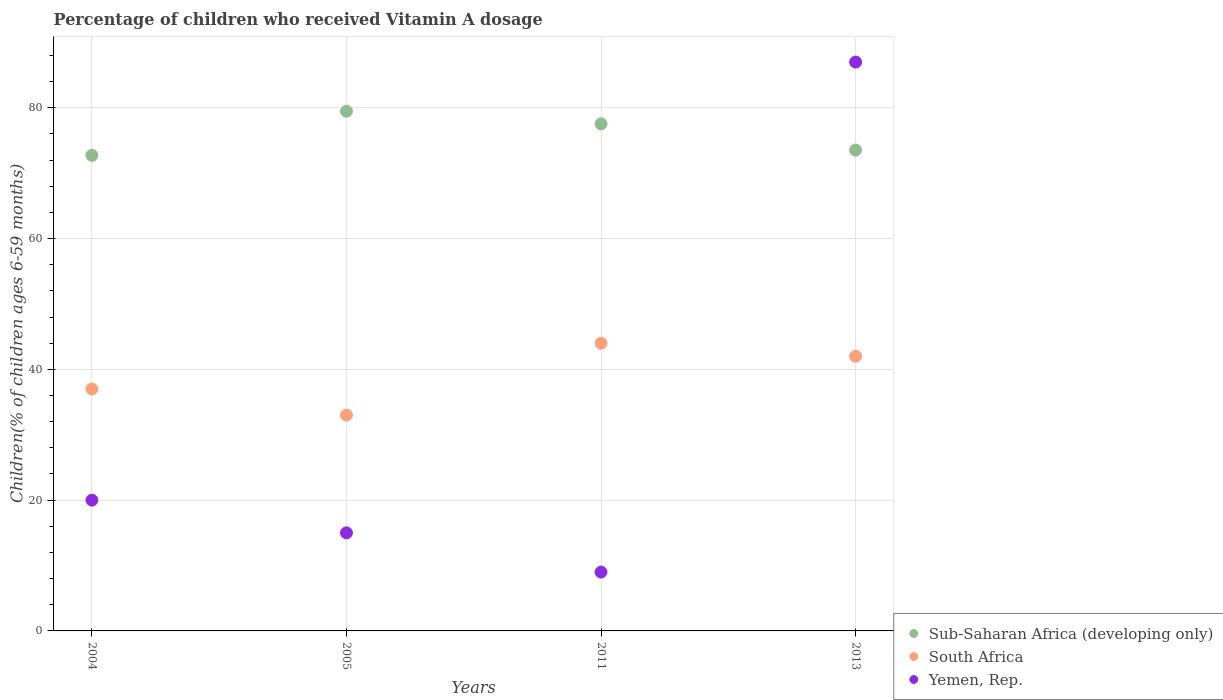What is the percentage of children who received Vitamin A dosage in Yemen, Rep. in 2005?
Keep it short and to the point. 15. Across all years, what is the maximum percentage of children who received Vitamin A dosage in Sub-Saharan Africa (developing only)?
Make the answer very short. 79.48. Across all years, what is the minimum percentage of children who received Vitamin A dosage in Sub-Saharan Africa (developing only)?
Ensure brevity in your answer.  72.73. In which year was the percentage of children who received Vitamin A dosage in Sub-Saharan Africa (developing only) minimum?
Keep it short and to the point. 2004. What is the total percentage of children who received Vitamin A dosage in South Africa in the graph?
Offer a terse response. 156. What is the difference between the percentage of children who received Vitamin A dosage in Yemen, Rep. in 2004 and that in 2013?
Keep it short and to the point. -67. What is the difference between the percentage of children who received Vitamin A dosage in Sub-Saharan Africa (developing only) in 2011 and the percentage of children who received Vitamin A dosage in Yemen, Rep. in 2013?
Give a very brief answer. -9.44. What is the average percentage of children who received Vitamin A dosage in South Africa per year?
Provide a short and direct response. 39. In the year 2005, what is the difference between the percentage of children who received Vitamin A dosage in South Africa and percentage of children who received Vitamin A dosage in Sub-Saharan Africa (developing only)?
Ensure brevity in your answer.  -46.48. In how many years, is the percentage of children who received Vitamin A dosage in Yemen, Rep. greater than 8 %?
Your response must be concise. 4. What is the ratio of the percentage of children who received Vitamin A dosage in Yemen, Rep. in 2004 to that in 2005?
Your answer should be compact. 1.33. Is the difference between the percentage of children who received Vitamin A dosage in South Africa in 2004 and 2011 greater than the difference between the percentage of children who received Vitamin A dosage in Sub-Saharan Africa (developing only) in 2004 and 2011?
Provide a short and direct response. No. What is the difference between the highest and the second highest percentage of children who received Vitamin A dosage in Sub-Saharan Africa (developing only)?
Offer a terse response. 1.92. Are the values on the major ticks of Y-axis written in scientific E-notation?
Give a very brief answer. No. Does the graph contain grids?
Your answer should be very brief. Yes. How are the legend labels stacked?
Your response must be concise. Vertical. What is the title of the graph?
Provide a short and direct response. Percentage of children who received Vitamin A dosage. Does "Middle income" appear as one of the legend labels in the graph?
Provide a succinct answer. No. What is the label or title of the Y-axis?
Make the answer very short. Children(% of children ages 6-59 months). What is the Children(% of children ages 6-59 months) of Sub-Saharan Africa (developing only) in 2004?
Provide a short and direct response. 72.73. What is the Children(% of children ages 6-59 months) in Yemen, Rep. in 2004?
Your response must be concise. 20. What is the Children(% of children ages 6-59 months) of Sub-Saharan Africa (developing only) in 2005?
Your answer should be compact. 79.48. What is the Children(% of children ages 6-59 months) in South Africa in 2005?
Keep it short and to the point. 33. What is the Children(% of children ages 6-59 months) in Yemen, Rep. in 2005?
Your answer should be compact. 15. What is the Children(% of children ages 6-59 months) of Sub-Saharan Africa (developing only) in 2011?
Your answer should be compact. 77.56. What is the Children(% of children ages 6-59 months) in South Africa in 2011?
Ensure brevity in your answer.  44. What is the Children(% of children ages 6-59 months) in Yemen, Rep. in 2011?
Provide a short and direct response. 9. What is the Children(% of children ages 6-59 months) in Sub-Saharan Africa (developing only) in 2013?
Your answer should be very brief. 73.54. What is the Children(% of children ages 6-59 months) in Yemen, Rep. in 2013?
Give a very brief answer. 87. Across all years, what is the maximum Children(% of children ages 6-59 months) in Sub-Saharan Africa (developing only)?
Make the answer very short. 79.48. Across all years, what is the maximum Children(% of children ages 6-59 months) in South Africa?
Your answer should be compact. 44. Across all years, what is the maximum Children(% of children ages 6-59 months) in Yemen, Rep.?
Provide a short and direct response. 87. Across all years, what is the minimum Children(% of children ages 6-59 months) of Sub-Saharan Africa (developing only)?
Your answer should be very brief. 72.73. Across all years, what is the minimum Children(% of children ages 6-59 months) in South Africa?
Ensure brevity in your answer.  33. Across all years, what is the minimum Children(% of children ages 6-59 months) of Yemen, Rep.?
Your response must be concise. 9. What is the total Children(% of children ages 6-59 months) of Sub-Saharan Africa (developing only) in the graph?
Your answer should be compact. 303.3. What is the total Children(% of children ages 6-59 months) of South Africa in the graph?
Ensure brevity in your answer.  156. What is the total Children(% of children ages 6-59 months) of Yemen, Rep. in the graph?
Offer a terse response. 131. What is the difference between the Children(% of children ages 6-59 months) in Sub-Saharan Africa (developing only) in 2004 and that in 2005?
Offer a terse response. -6.75. What is the difference between the Children(% of children ages 6-59 months) of Yemen, Rep. in 2004 and that in 2005?
Offer a very short reply. 5. What is the difference between the Children(% of children ages 6-59 months) in Sub-Saharan Africa (developing only) in 2004 and that in 2011?
Give a very brief answer. -4.83. What is the difference between the Children(% of children ages 6-59 months) in South Africa in 2004 and that in 2011?
Keep it short and to the point. -7. What is the difference between the Children(% of children ages 6-59 months) of Yemen, Rep. in 2004 and that in 2011?
Provide a short and direct response. 11. What is the difference between the Children(% of children ages 6-59 months) of Sub-Saharan Africa (developing only) in 2004 and that in 2013?
Your answer should be compact. -0.81. What is the difference between the Children(% of children ages 6-59 months) in Yemen, Rep. in 2004 and that in 2013?
Provide a short and direct response. -67. What is the difference between the Children(% of children ages 6-59 months) in Sub-Saharan Africa (developing only) in 2005 and that in 2011?
Provide a succinct answer. 1.92. What is the difference between the Children(% of children ages 6-59 months) of South Africa in 2005 and that in 2011?
Keep it short and to the point. -11. What is the difference between the Children(% of children ages 6-59 months) of Sub-Saharan Africa (developing only) in 2005 and that in 2013?
Your answer should be compact. 5.94. What is the difference between the Children(% of children ages 6-59 months) in South Africa in 2005 and that in 2013?
Give a very brief answer. -9. What is the difference between the Children(% of children ages 6-59 months) in Yemen, Rep. in 2005 and that in 2013?
Ensure brevity in your answer.  -72. What is the difference between the Children(% of children ages 6-59 months) in Sub-Saharan Africa (developing only) in 2011 and that in 2013?
Offer a terse response. 4.02. What is the difference between the Children(% of children ages 6-59 months) of South Africa in 2011 and that in 2013?
Make the answer very short. 2. What is the difference between the Children(% of children ages 6-59 months) in Yemen, Rep. in 2011 and that in 2013?
Keep it short and to the point. -78. What is the difference between the Children(% of children ages 6-59 months) of Sub-Saharan Africa (developing only) in 2004 and the Children(% of children ages 6-59 months) of South Africa in 2005?
Your answer should be compact. 39.73. What is the difference between the Children(% of children ages 6-59 months) in Sub-Saharan Africa (developing only) in 2004 and the Children(% of children ages 6-59 months) in Yemen, Rep. in 2005?
Give a very brief answer. 57.73. What is the difference between the Children(% of children ages 6-59 months) of South Africa in 2004 and the Children(% of children ages 6-59 months) of Yemen, Rep. in 2005?
Provide a succinct answer. 22. What is the difference between the Children(% of children ages 6-59 months) of Sub-Saharan Africa (developing only) in 2004 and the Children(% of children ages 6-59 months) of South Africa in 2011?
Give a very brief answer. 28.73. What is the difference between the Children(% of children ages 6-59 months) of Sub-Saharan Africa (developing only) in 2004 and the Children(% of children ages 6-59 months) of Yemen, Rep. in 2011?
Make the answer very short. 63.73. What is the difference between the Children(% of children ages 6-59 months) of Sub-Saharan Africa (developing only) in 2004 and the Children(% of children ages 6-59 months) of South Africa in 2013?
Your response must be concise. 30.73. What is the difference between the Children(% of children ages 6-59 months) of Sub-Saharan Africa (developing only) in 2004 and the Children(% of children ages 6-59 months) of Yemen, Rep. in 2013?
Your answer should be compact. -14.27. What is the difference between the Children(% of children ages 6-59 months) of Sub-Saharan Africa (developing only) in 2005 and the Children(% of children ages 6-59 months) of South Africa in 2011?
Your answer should be compact. 35.48. What is the difference between the Children(% of children ages 6-59 months) in Sub-Saharan Africa (developing only) in 2005 and the Children(% of children ages 6-59 months) in Yemen, Rep. in 2011?
Offer a terse response. 70.48. What is the difference between the Children(% of children ages 6-59 months) in South Africa in 2005 and the Children(% of children ages 6-59 months) in Yemen, Rep. in 2011?
Keep it short and to the point. 24. What is the difference between the Children(% of children ages 6-59 months) in Sub-Saharan Africa (developing only) in 2005 and the Children(% of children ages 6-59 months) in South Africa in 2013?
Your answer should be compact. 37.48. What is the difference between the Children(% of children ages 6-59 months) in Sub-Saharan Africa (developing only) in 2005 and the Children(% of children ages 6-59 months) in Yemen, Rep. in 2013?
Keep it short and to the point. -7.52. What is the difference between the Children(% of children ages 6-59 months) in South Africa in 2005 and the Children(% of children ages 6-59 months) in Yemen, Rep. in 2013?
Make the answer very short. -54. What is the difference between the Children(% of children ages 6-59 months) of Sub-Saharan Africa (developing only) in 2011 and the Children(% of children ages 6-59 months) of South Africa in 2013?
Keep it short and to the point. 35.56. What is the difference between the Children(% of children ages 6-59 months) of Sub-Saharan Africa (developing only) in 2011 and the Children(% of children ages 6-59 months) of Yemen, Rep. in 2013?
Make the answer very short. -9.44. What is the difference between the Children(% of children ages 6-59 months) of South Africa in 2011 and the Children(% of children ages 6-59 months) of Yemen, Rep. in 2013?
Your answer should be compact. -43. What is the average Children(% of children ages 6-59 months) of Sub-Saharan Africa (developing only) per year?
Provide a succinct answer. 75.83. What is the average Children(% of children ages 6-59 months) in Yemen, Rep. per year?
Keep it short and to the point. 32.75. In the year 2004, what is the difference between the Children(% of children ages 6-59 months) of Sub-Saharan Africa (developing only) and Children(% of children ages 6-59 months) of South Africa?
Your answer should be very brief. 35.73. In the year 2004, what is the difference between the Children(% of children ages 6-59 months) in Sub-Saharan Africa (developing only) and Children(% of children ages 6-59 months) in Yemen, Rep.?
Make the answer very short. 52.73. In the year 2005, what is the difference between the Children(% of children ages 6-59 months) in Sub-Saharan Africa (developing only) and Children(% of children ages 6-59 months) in South Africa?
Make the answer very short. 46.48. In the year 2005, what is the difference between the Children(% of children ages 6-59 months) in Sub-Saharan Africa (developing only) and Children(% of children ages 6-59 months) in Yemen, Rep.?
Provide a succinct answer. 64.48. In the year 2005, what is the difference between the Children(% of children ages 6-59 months) in South Africa and Children(% of children ages 6-59 months) in Yemen, Rep.?
Keep it short and to the point. 18. In the year 2011, what is the difference between the Children(% of children ages 6-59 months) in Sub-Saharan Africa (developing only) and Children(% of children ages 6-59 months) in South Africa?
Your answer should be very brief. 33.56. In the year 2011, what is the difference between the Children(% of children ages 6-59 months) of Sub-Saharan Africa (developing only) and Children(% of children ages 6-59 months) of Yemen, Rep.?
Offer a terse response. 68.56. In the year 2013, what is the difference between the Children(% of children ages 6-59 months) of Sub-Saharan Africa (developing only) and Children(% of children ages 6-59 months) of South Africa?
Give a very brief answer. 31.54. In the year 2013, what is the difference between the Children(% of children ages 6-59 months) of Sub-Saharan Africa (developing only) and Children(% of children ages 6-59 months) of Yemen, Rep.?
Make the answer very short. -13.46. In the year 2013, what is the difference between the Children(% of children ages 6-59 months) in South Africa and Children(% of children ages 6-59 months) in Yemen, Rep.?
Provide a short and direct response. -45. What is the ratio of the Children(% of children ages 6-59 months) in Sub-Saharan Africa (developing only) in 2004 to that in 2005?
Offer a terse response. 0.92. What is the ratio of the Children(% of children ages 6-59 months) of South Africa in 2004 to that in 2005?
Your answer should be very brief. 1.12. What is the ratio of the Children(% of children ages 6-59 months) of Yemen, Rep. in 2004 to that in 2005?
Make the answer very short. 1.33. What is the ratio of the Children(% of children ages 6-59 months) in Sub-Saharan Africa (developing only) in 2004 to that in 2011?
Make the answer very short. 0.94. What is the ratio of the Children(% of children ages 6-59 months) of South Africa in 2004 to that in 2011?
Provide a short and direct response. 0.84. What is the ratio of the Children(% of children ages 6-59 months) in Yemen, Rep. in 2004 to that in 2011?
Offer a terse response. 2.22. What is the ratio of the Children(% of children ages 6-59 months) in South Africa in 2004 to that in 2013?
Keep it short and to the point. 0.88. What is the ratio of the Children(% of children ages 6-59 months) in Yemen, Rep. in 2004 to that in 2013?
Provide a short and direct response. 0.23. What is the ratio of the Children(% of children ages 6-59 months) of Sub-Saharan Africa (developing only) in 2005 to that in 2011?
Your answer should be very brief. 1.02. What is the ratio of the Children(% of children ages 6-59 months) in South Africa in 2005 to that in 2011?
Offer a very short reply. 0.75. What is the ratio of the Children(% of children ages 6-59 months) of Yemen, Rep. in 2005 to that in 2011?
Give a very brief answer. 1.67. What is the ratio of the Children(% of children ages 6-59 months) of Sub-Saharan Africa (developing only) in 2005 to that in 2013?
Provide a short and direct response. 1.08. What is the ratio of the Children(% of children ages 6-59 months) in South Africa in 2005 to that in 2013?
Keep it short and to the point. 0.79. What is the ratio of the Children(% of children ages 6-59 months) in Yemen, Rep. in 2005 to that in 2013?
Keep it short and to the point. 0.17. What is the ratio of the Children(% of children ages 6-59 months) of Sub-Saharan Africa (developing only) in 2011 to that in 2013?
Keep it short and to the point. 1.05. What is the ratio of the Children(% of children ages 6-59 months) in South Africa in 2011 to that in 2013?
Make the answer very short. 1.05. What is the ratio of the Children(% of children ages 6-59 months) in Yemen, Rep. in 2011 to that in 2013?
Offer a very short reply. 0.1. What is the difference between the highest and the second highest Children(% of children ages 6-59 months) in Sub-Saharan Africa (developing only)?
Keep it short and to the point. 1.92. What is the difference between the highest and the second highest Children(% of children ages 6-59 months) in South Africa?
Offer a terse response. 2. What is the difference between the highest and the second highest Children(% of children ages 6-59 months) in Yemen, Rep.?
Your answer should be very brief. 67. What is the difference between the highest and the lowest Children(% of children ages 6-59 months) of Sub-Saharan Africa (developing only)?
Give a very brief answer. 6.75. What is the difference between the highest and the lowest Children(% of children ages 6-59 months) in South Africa?
Provide a short and direct response. 11. 